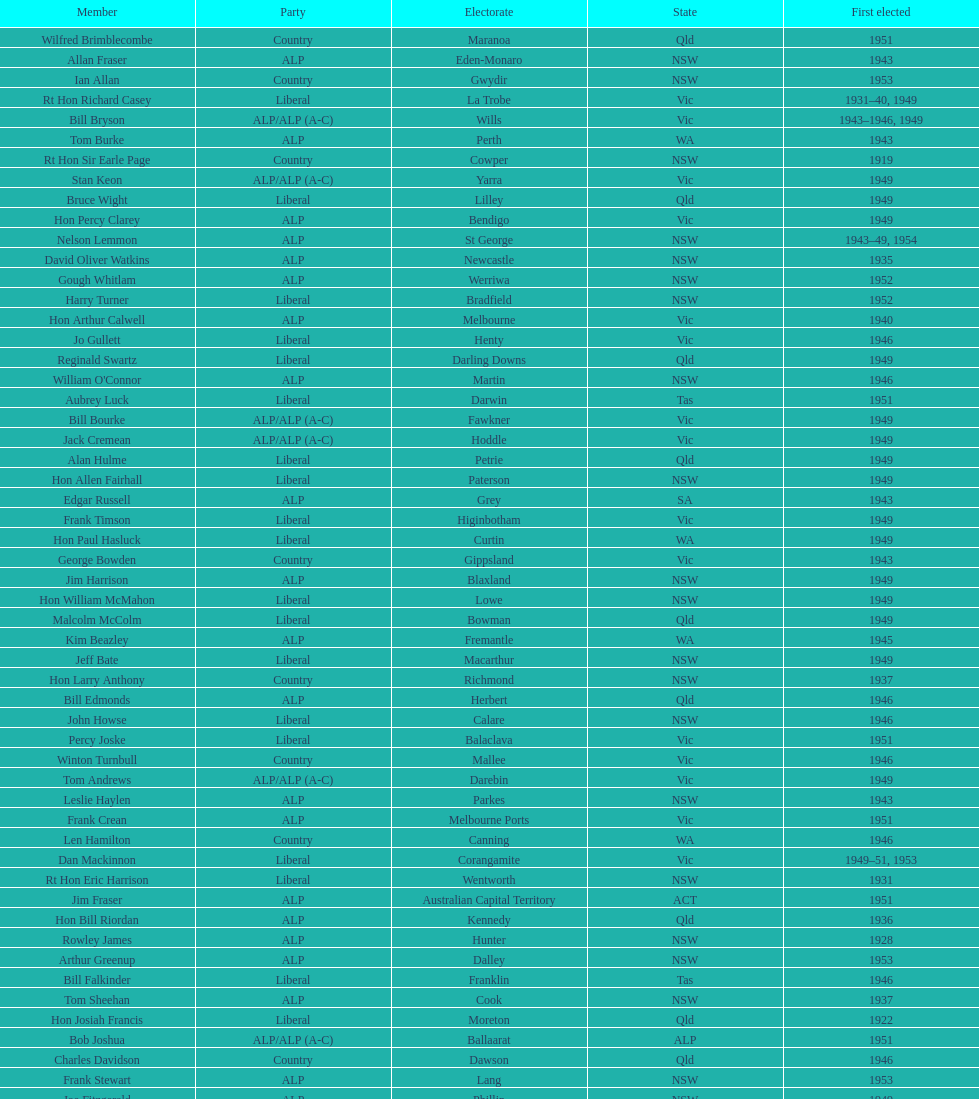What is the number of alp party members elected? 57. 